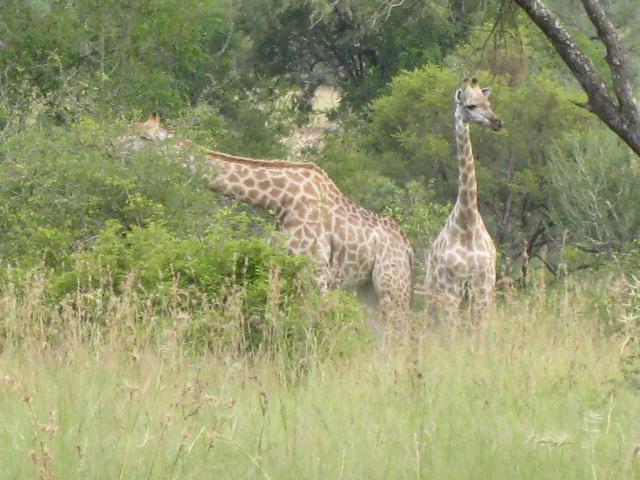How many giraffes are there?
Give a very brief answer. 2. How many giraffes are looking toward the camera?
Give a very brief answer. 1. How many giraffes can be seen?
Give a very brief answer. 2. 